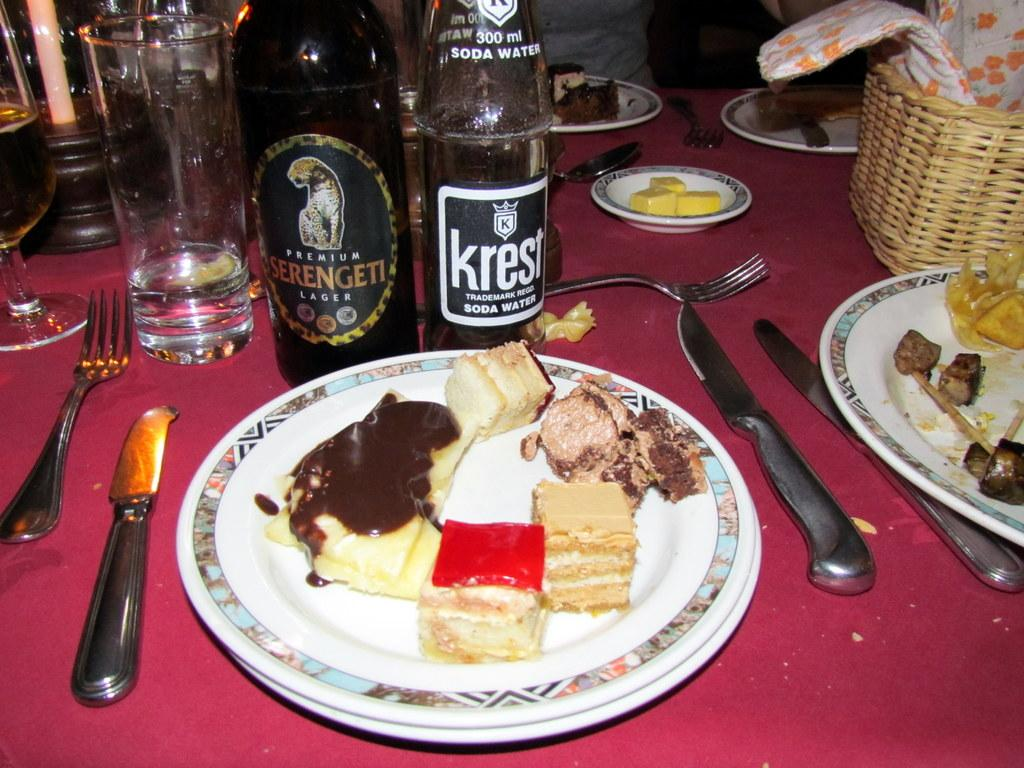<image>
Share a concise interpretation of the image provided. A bottle of Krest on a table next to a plate of food. 